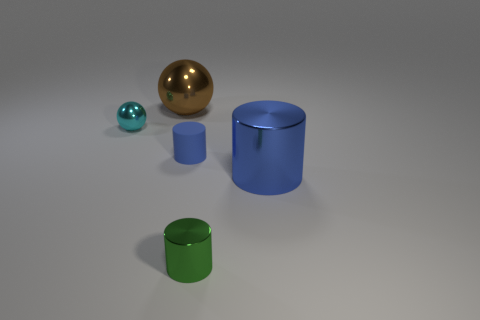Subtract all tiny metallic cylinders. How many cylinders are left? 2 Add 2 shiny cylinders. How many objects exist? 7 Subtract all cyan cubes. How many blue cylinders are left? 2 Subtract 1 cylinders. How many cylinders are left? 2 Subtract all cyan balls. How many balls are left? 1 Subtract all tiny blue things. Subtract all large brown metallic things. How many objects are left? 3 Add 1 blue matte cylinders. How many blue matte cylinders are left? 2 Add 4 green cylinders. How many green cylinders exist? 5 Subtract 0 purple balls. How many objects are left? 5 Subtract all spheres. How many objects are left? 3 